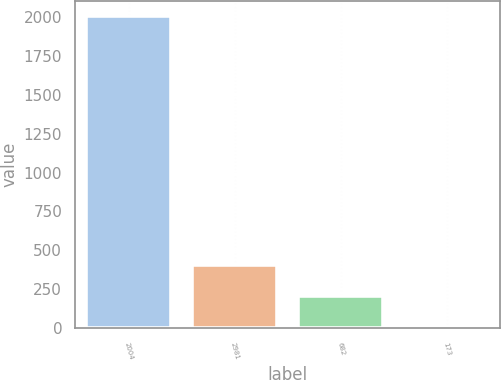Convert chart to OTSL. <chart><loc_0><loc_0><loc_500><loc_500><bar_chart><fcel>2004<fcel>2981<fcel>682<fcel>173<nl><fcel>2003<fcel>404.12<fcel>204.26<fcel>4.4<nl></chart> 